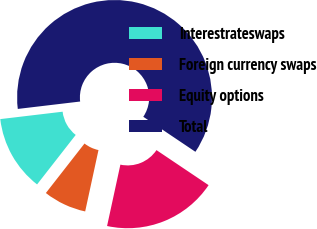<chart> <loc_0><loc_0><loc_500><loc_500><pie_chart><fcel>Interestrateswaps<fcel>Foreign currency swaps<fcel>Equity options<fcel>Total<nl><fcel>12.57%<fcel>7.15%<fcel>18.98%<fcel>61.3%<nl></chart> 